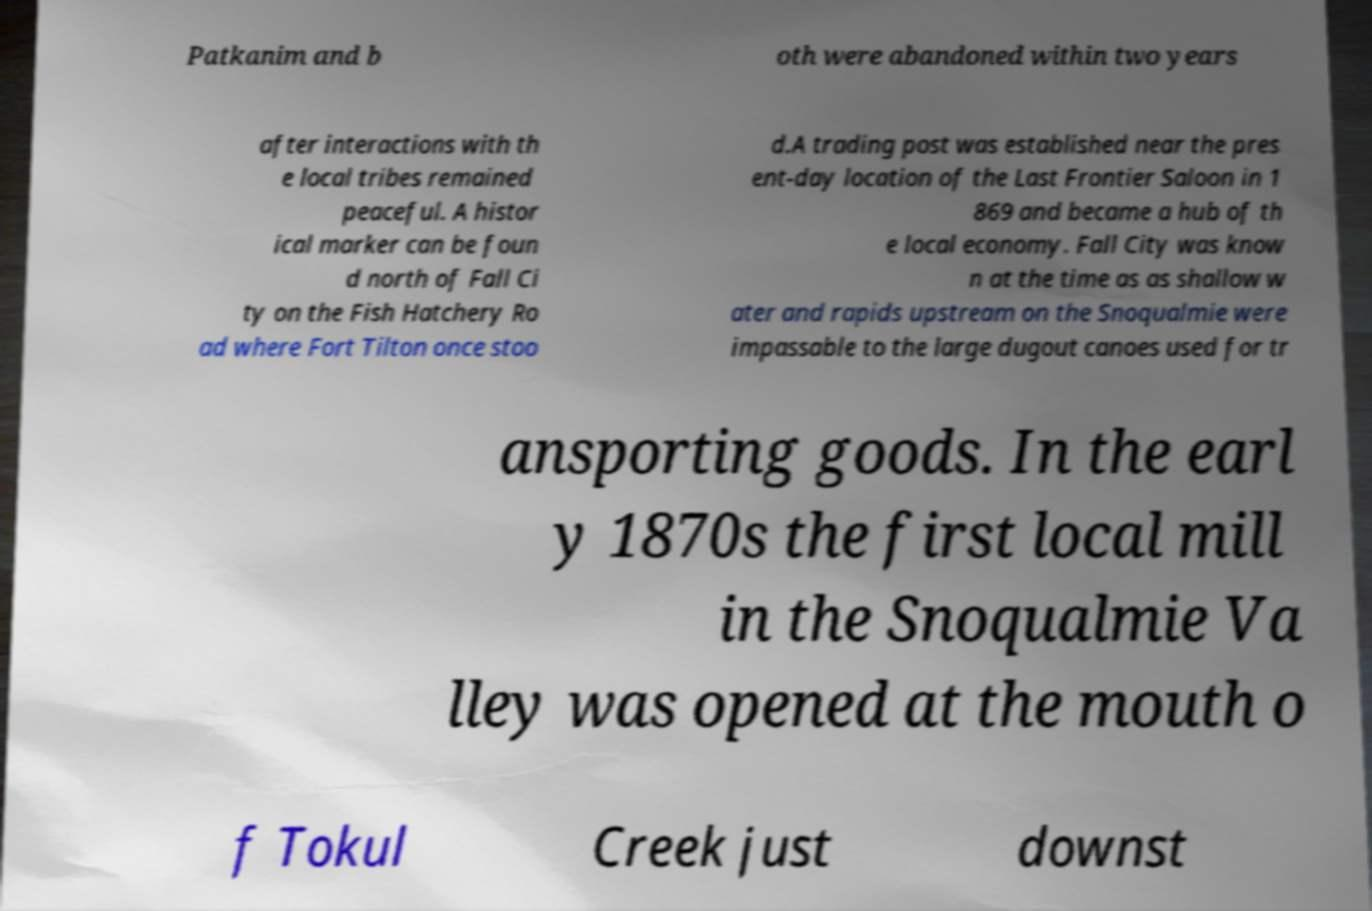Could you extract and type out the text from this image? Patkanim and b oth were abandoned within two years after interactions with th e local tribes remained peaceful. A histor ical marker can be foun d north of Fall Ci ty on the Fish Hatchery Ro ad where Fort Tilton once stoo d.A trading post was established near the pres ent-day location of the Last Frontier Saloon in 1 869 and became a hub of th e local economy. Fall City was know n at the time as as shallow w ater and rapids upstream on the Snoqualmie were impassable to the large dugout canoes used for tr ansporting goods. In the earl y 1870s the first local mill in the Snoqualmie Va lley was opened at the mouth o f Tokul Creek just downst 